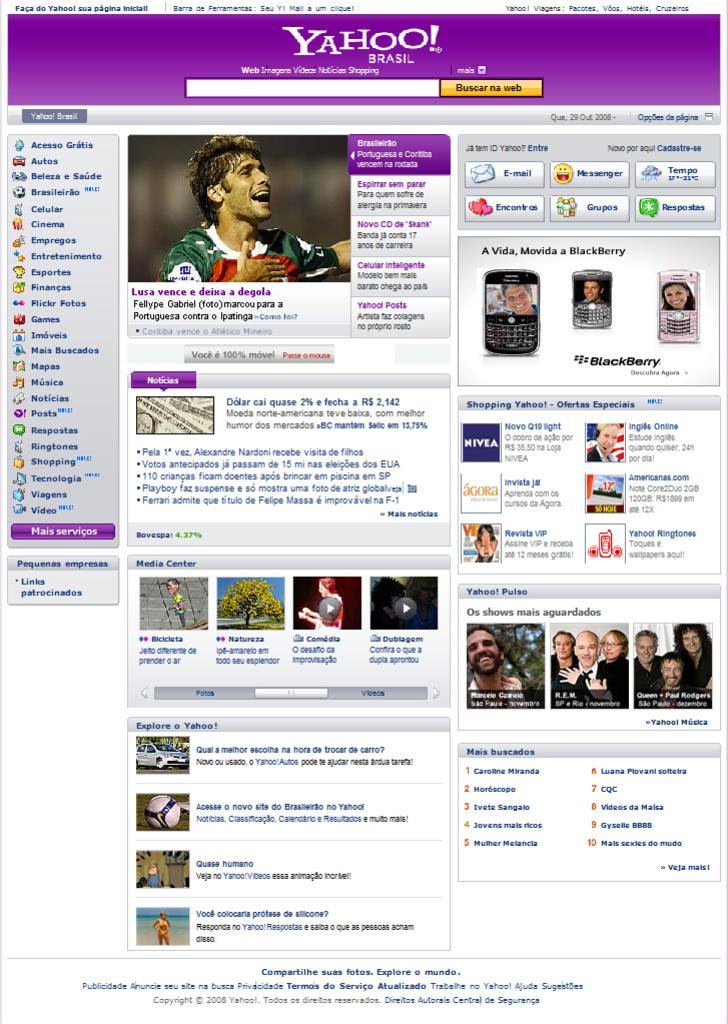Who or what can be seen in the image? There are people in the image. What objects are related to technology in the image? There are apps and mobiles in the image. What mode of transportation is present in the image? There is a car in the image. What type of object is round and can be used for playing in the image? There is a ball in the image. What type of plant is visible in the image? There is a tree in the image. What can be seen in the background of the image? There is text visible in the background of the image. What type of wine is being served at the event in the image? There is no event or wine present in the image. How many hands are visible in the image? There is no mention of hands in the provided facts, so it cannot be determined from the image. 